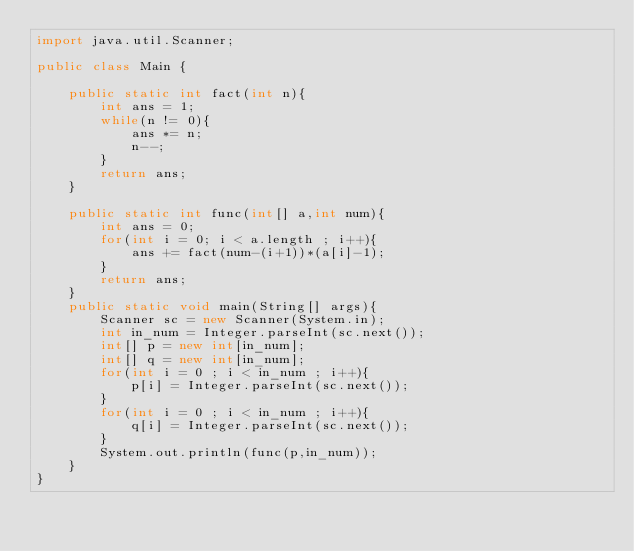Convert code to text. <code><loc_0><loc_0><loc_500><loc_500><_Java_>import java.util.Scanner;

public class Main {

    public static int fact(int n){
        int ans = 1;
        while(n != 0){
            ans *= n;
            n--;
        }
        return ans;
    }

    public static int func(int[] a,int num){
        int ans = 0;
        for(int i = 0; i < a.length ; i++){
            ans += fact(num-(i+1))*(a[i]-1);
        }
        return ans;
    }
    public static void main(String[] args){
        Scanner sc = new Scanner(System.in);
        int in_num = Integer.parseInt(sc.next());
        int[] p = new int[in_num];
        int[] q = new int[in_num];
        for(int i = 0 ; i < in_num ; i++){
            p[i] = Integer.parseInt(sc.next());
        }
        for(int i = 0 ; i < in_num ; i++){
            q[i] = Integer.parseInt(sc.next());
        }
        System.out.println(func(p,in_num));
    }
}</code> 